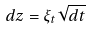<formula> <loc_0><loc_0><loc_500><loc_500>d z = \xi _ { t } \sqrt { d t }</formula> 